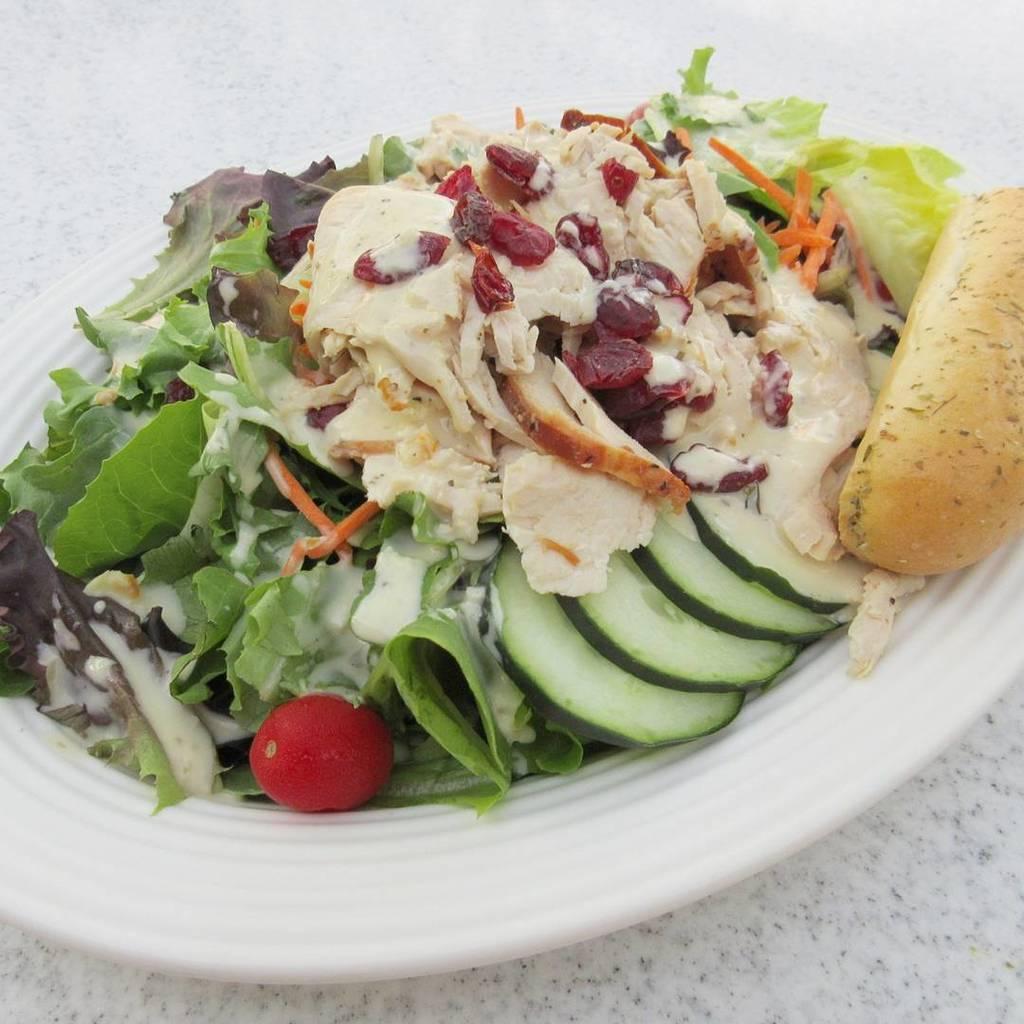Can you describe this image briefly? In the image we can see a plate, in the plate we can see salad, like cut vegetables and leaves and the plate is kept on the white marble. 